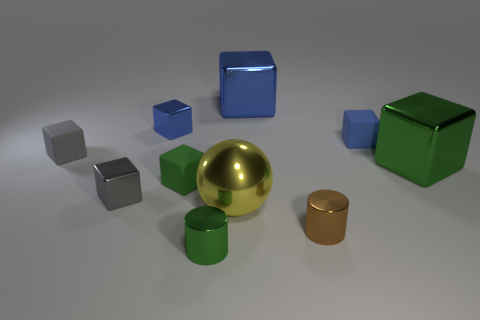Subtract all small blue matte cubes. How many cubes are left? 6 Subtract 2 cubes. How many cubes are left? 5 Subtract all cylinders. How many objects are left? 8 Subtract all brown cylinders. How many cylinders are left? 1 Subtract all yellow blocks. Subtract all gray balls. How many blocks are left? 7 Subtract all yellow cubes. How many purple spheres are left? 0 Subtract all big spheres. Subtract all tiny gray things. How many objects are left? 7 Add 4 small cylinders. How many small cylinders are left? 6 Add 8 tiny brown metal cubes. How many tiny brown metal cubes exist? 8 Subtract 0 cyan blocks. How many objects are left? 10 